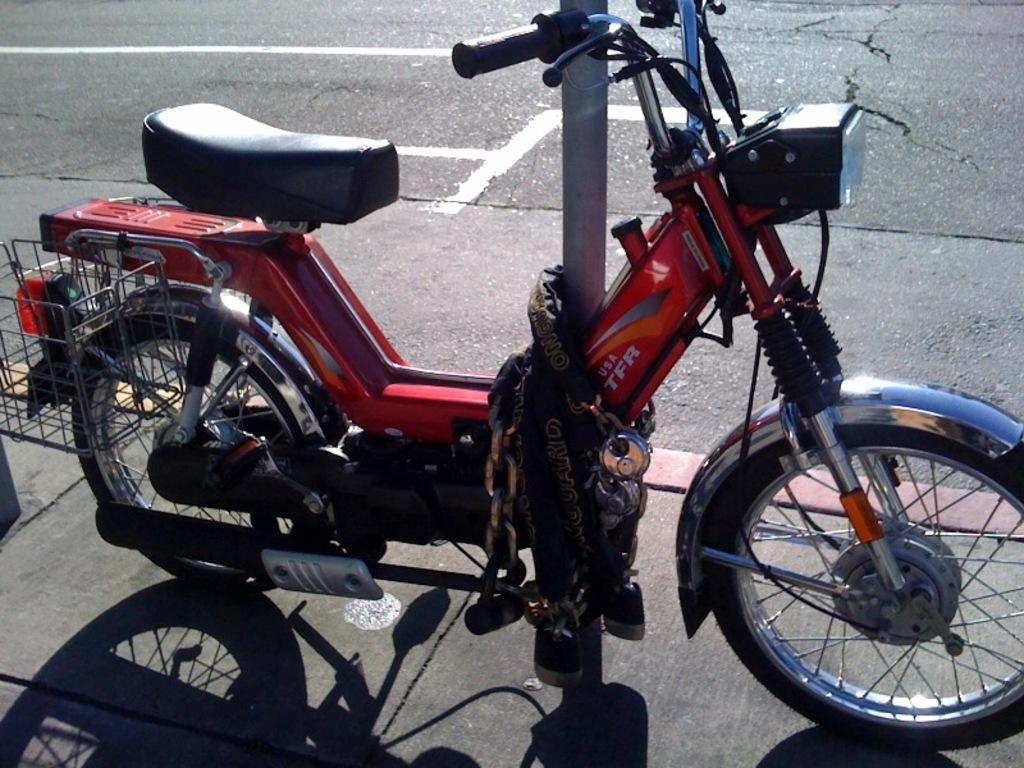What type of motor vehicle is in the image? The type of motor vehicle is not specified in the facts. Where is the motor vehicle located in the image? The motor vehicle is on the ground in the image. How is the motor vehicle secured in the image? The motor vehicle is tied to a pole with chains in the image. Can you see a pig wearing a mask and holding a bottle of poison in the image? No, there is no pig, mask, or poison present in the image. 